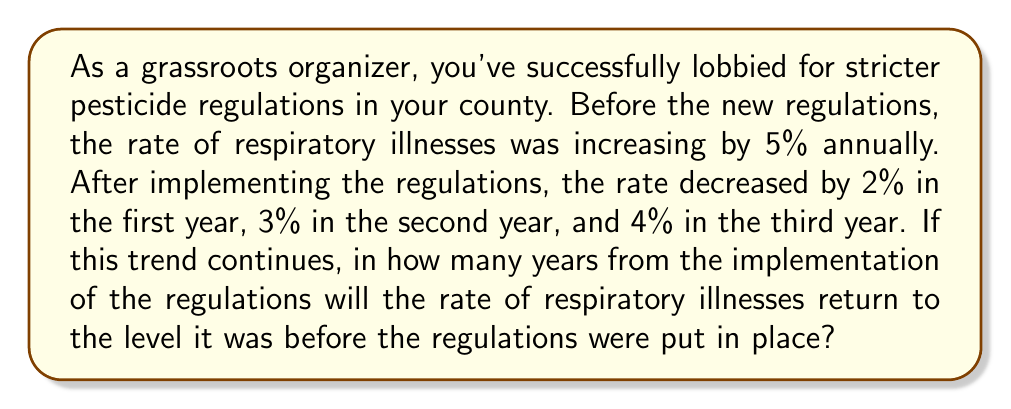Can you solve this math problem? Let's approach this step-by-step:

1) First, let's define our variables:
   Let $x$ be the number of years after implementation
   Let $y$ be the rate of respiratory illnesses as a percentage of the initial rate

2) We can express $y$ as a function of $x$:
   $$y = 100 \cdot (0.98 \cdot 0.97 \cdot 0.96 \cdot 0.96^{x-3})$$
   
   This is because:
   - In year 1, it decreased to 98% of the initial rate
   - In year 2, it decreased to 97% of that
   - In year 3, it decreased to 96% of that
   - For each subsequent year, we assume it continues to decrease by 4% (or to 96% of the previous year)

3) We want to find when $y$ returns to 100%. So we need to solve:
   $$100 = 100 \cdot (0.98 \cdot 0.97 \cdot 0.96 \cdot 0.96^{x-3})$$

4) Simplify:
   $$1 = 0.98 \cdot 0.97 \cdot 0.96 \cdot 0.96^{x-3}$$
   $$1 = 0.912384 \cdot 0.96^{x-3}$$

5) Take natural log of both sides:
   $$0 = \ln(0.912384) + (x-3)\ln(0.96)$$

6) Solve for $x$:
   $$x = 3 - \frac{\ln(0.912384)}{\ln(0.96)} \approx 5.3$$

7) Since we need a whole number of years, we round up to 6 years.
Answer: It will take 6 years from the implementation of the regulations for the rate of respiratory illnesses to return to its pre-regulation level. 